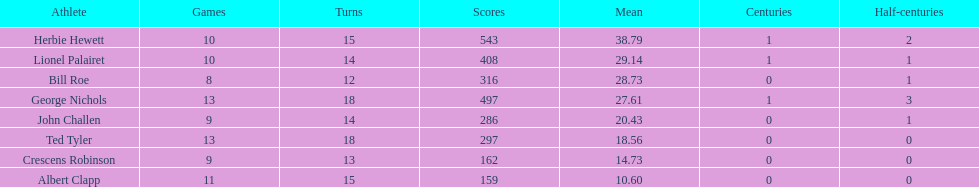What is the least about of runs anyone has? 159. Help me parse the entirety of this table. {'header': ['Athlete', 'Games', 'Turns', 'Scores', 'Mean', 'Centuries', 'Half-centuries'], 'rows': [['Herbie Hewett', '10', '15', '543', '38.79', '1', '2'], ['Lionel Palairet', '10', '14', '408', '29.14', '1', '1'], ['Bill Roe', '8', '12', '316', '28.73', '0', '1'], ['George Nichols', '13', '18', '497', '27.61', '1', '3'], ['John Challen', '9', '14', '286', '20.43', '0', '1'], ['Ted Tyler', '13', '18', '297', '18.56', '0', '0'], ['Crescens Robinson', '9', '13', '162', '14.73', '0', '0'], ['Albert Clapp', '11', '15', '159', '10.60', '0', '0']]} 